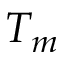<formula> <loc_0><loc_0><loc_500><loc_500>T _ { m }</formula> 